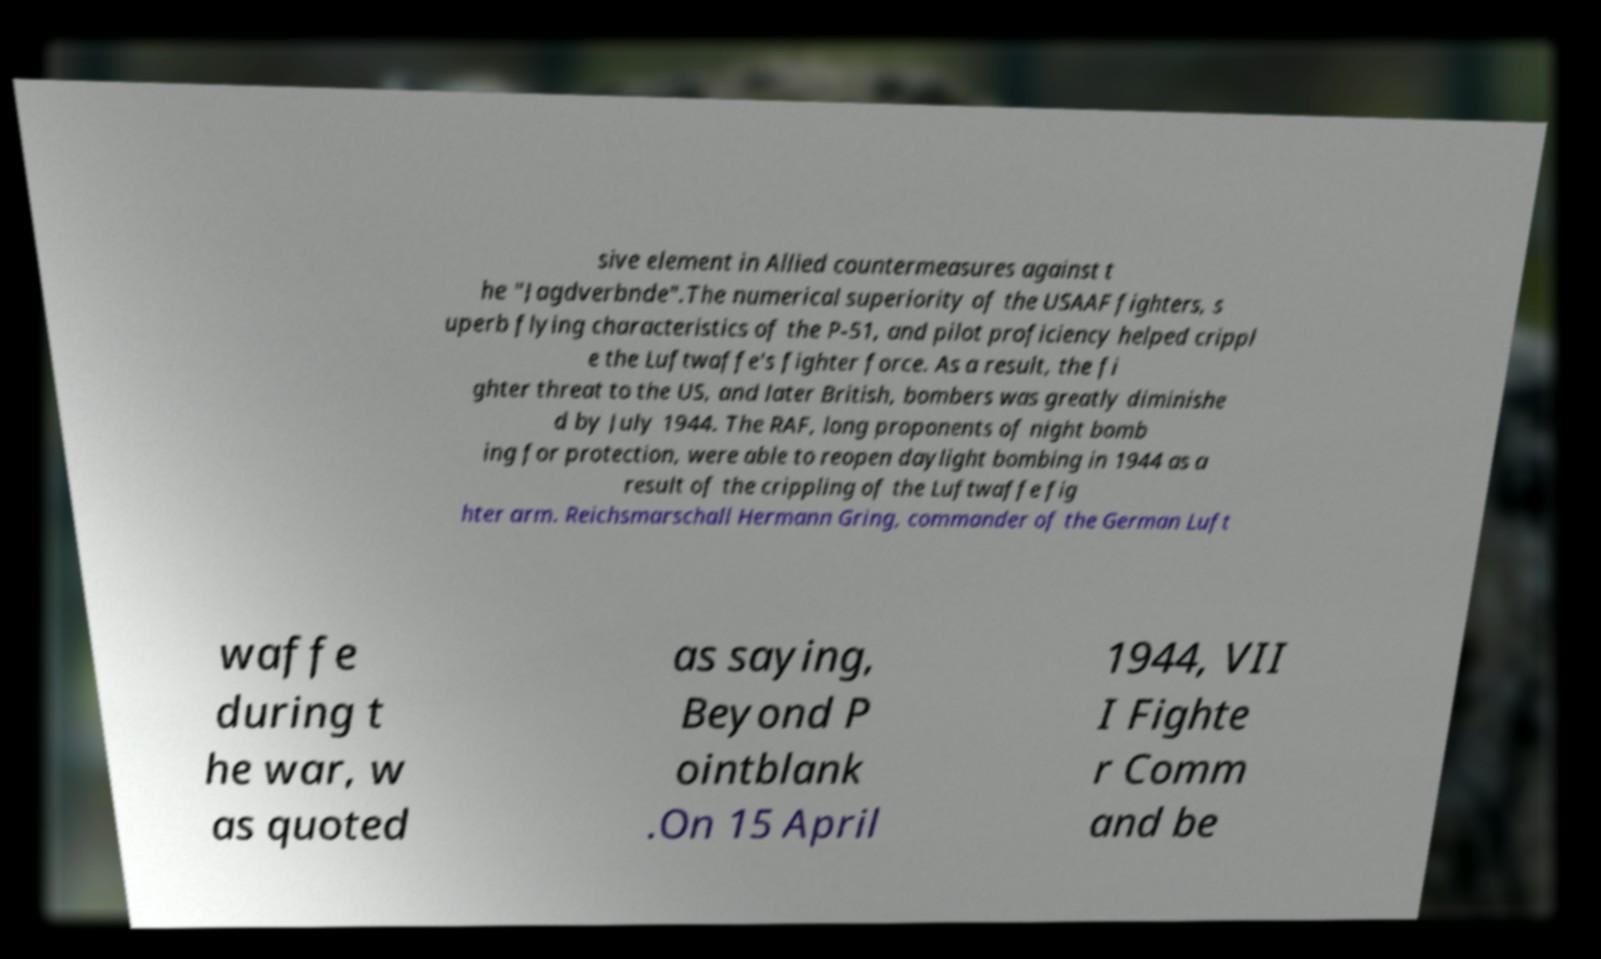Could you extract and type out the text from this image? sive element in Allied countermeasures against t he "Jagdverbnde".The numerical superiority of the USAAF fighters, s uperb flying characteristics of the P-51, and pilot proficiency helped crippl e the Luftwaffe's fighter force. As a result, the fi ghter threat to the US, and later British, bombers was greatly diminishe d by July 1944. The RAF, long proponents of night bomb ing for protection, were able to reopen daylight bombing in 1944 as a result of the crippling of the Luftwaffe fig hter arm. Reichsmarschall Hermann Gring, commander of the German Luft waffe during t he war, w as quoted as saying, Beyond P ointblank .On 15 April 1944, VII I Fighte r Comm and be 